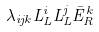Convert formula to latex. <formula><loc_0><loc_0><loc_500><loc_500>\lambda _ { i j k } L _ { L } ^ { i } L _ { L } ^ { j } { \bar { E } } _ { R } ^ { k }</formula> 